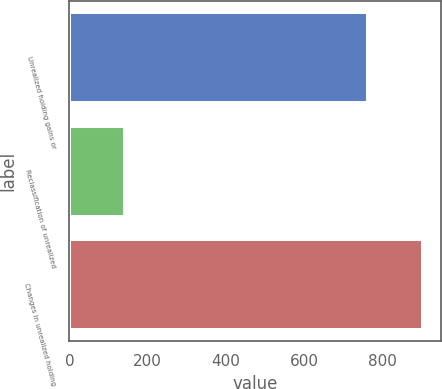Convert chart. <chart><loc_0><loc_0><loc_500><loc_500><bar_chart><fcel>Unrealized holding gains or<fcel>Reclassification of unrealized<fcel>Changes in unrealized holding<nl><fcel>764<fcel>141<fcel>905<nl></chart> 